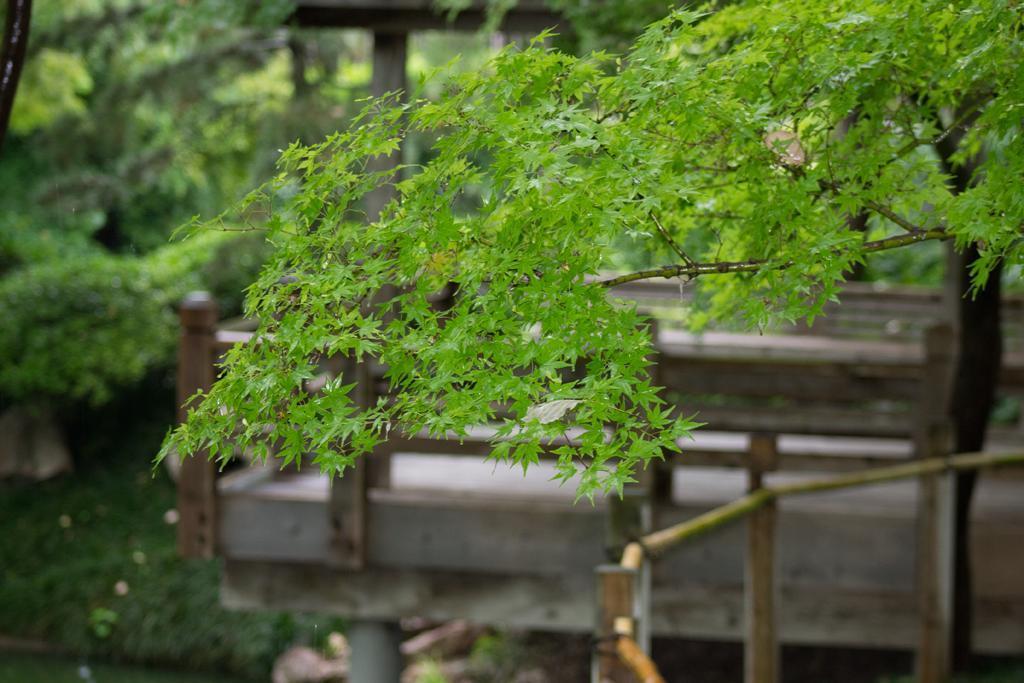Please provide a concise description of this image. In this image there are plants towards the left of the image, there is a plant towards the top of the image, there is a wooden object towards the right of the image, there is grass towards the bottom of the image, there is an object towards the bottom of the image. 